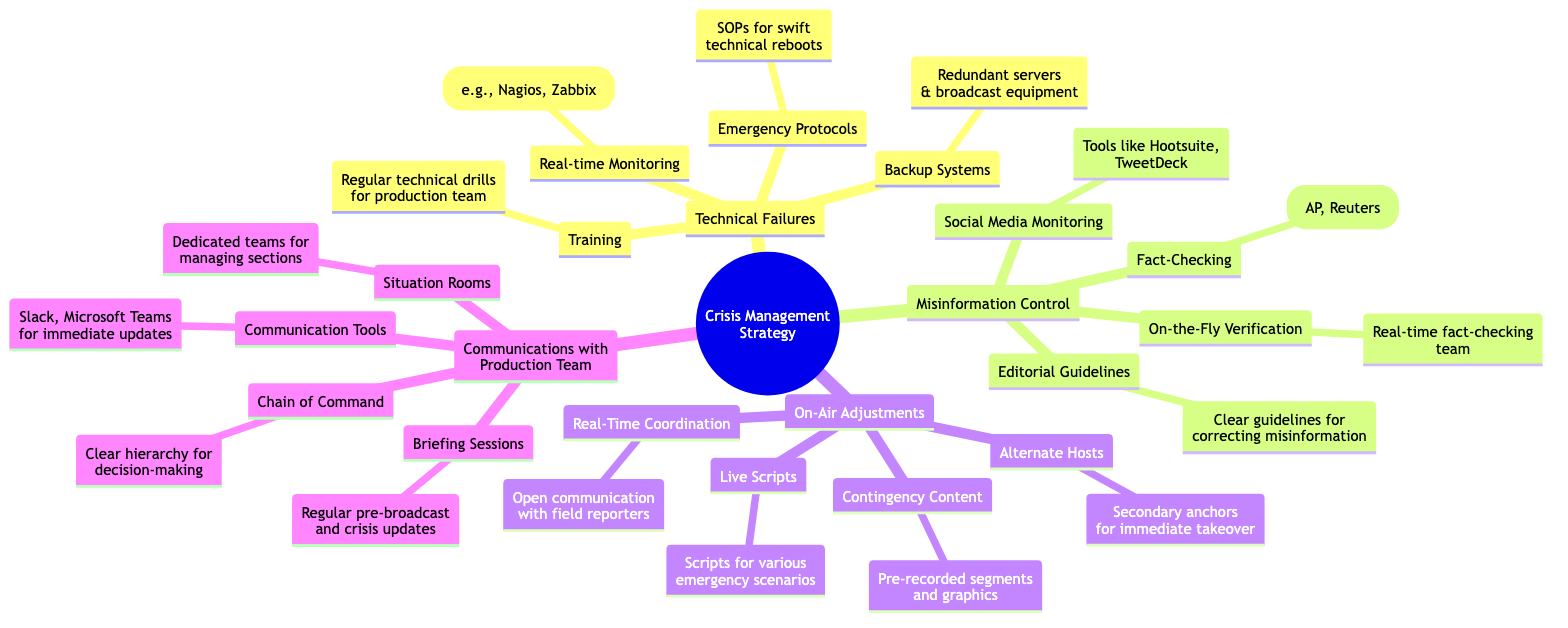What are the components of Technical Failures? The node "Technical Failures" has four sub-nodes: "Backup Systems," "Real-time Monitoring," "Emergency Protocols," and "Training." These represent the key areas within managing technical failures.
Answer: Backup Systems, Real-time Monitoring, Emergency Protocols, Training How many main categories are present in the diagram? The diagram presents four main categories under the "Crisis Management Strategy": "Technical Failures," "Misinformation Control," "On-Air Adjustments," and "Communications with Production Team." Counting these gives a total of four categories.
Answer: 4 What tool is mentioned for monitoring social media? The node "Social Media Monitoring" specifically mentions tools like "Hootsuite" and "TweetDeck." These tools are utilized for tracking and countering false narratives on social media.
Answer: Hootsuite, TweetDeck What type of content should be prepared as Contingency Content? The node "Contingency Content" specifies the need for "Pre-recorded segments and graphics." This indicates the type of content intended to be used during unforeseen disruptions.
Answer: Pre-recorded segments and graphics What are the emergency communication tools mentioned? The "Communication Tools" node lists "Slack" and "Microsoft Teams," which are indicated as tools for immediate updates and communication among the production team during crises.
Answer: Slack, Microsoft Teams What is the purpose of 'Alternate Hosts'? The node "Alternate Hosts" indicates that secondary anchors are identified and ready for "immediate takeover" during a crisis. This highlights the purpose of having additional personnel prepared for broadcasting.
Answer: Immediate takeover What does the 'Chain of Command' ensure? The "Chain of Command" node emphasizes a clear hierarchy for decision-making during crises, ensuring that roles and responsibilities are well-defined when unexpected situations arise.
Answer: Clear hierarchy for decision-making What role do Situation Rooms play in the strategy? The "Situation Rooms" node indicates that dedicated teams manage different sections such as technical and editorial, providing focused oversight and management during a crisis.
Answer: Managing different sections How often should Briefing Sessions be conducted? The "Briefing Sessions" node suggests that regular pre-broadcast briefings and updates should occur during crises. This implies ongoing communication is essential to ensure readiness.
Answer: Regular updates during issues 